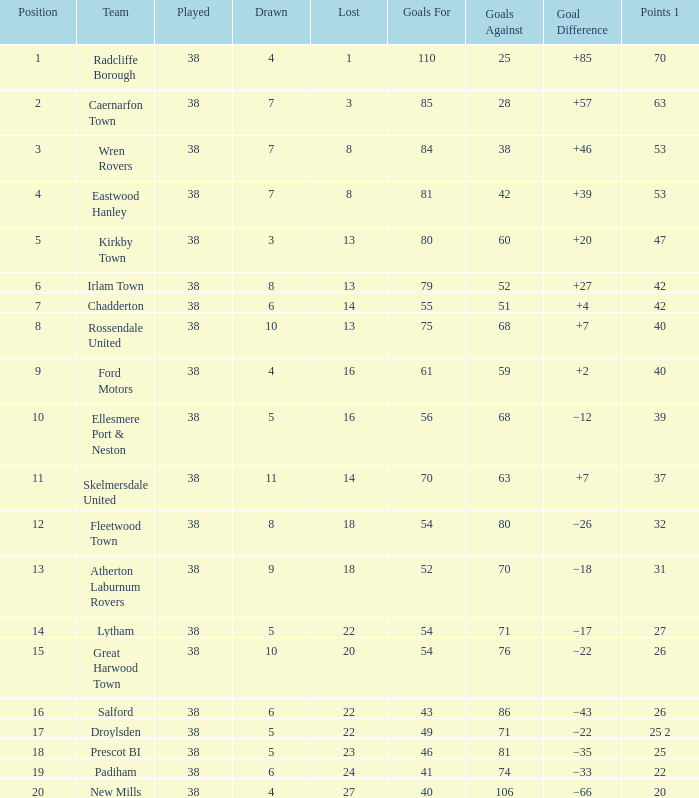Which lost possesses a standing above 5, and points 1 of 37, and not more than 63 goals against? None. 